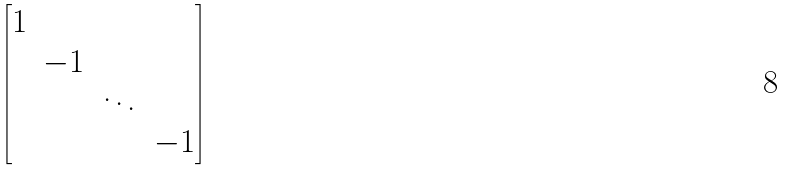<formula> <loc_0><loc_0><loc_500><loc_500>\begin{bmatrix} 1 & & & \\ & - 1 & & \\ & & \ddots & \\ & & & - 1 \end{bmatrix}</formula> 